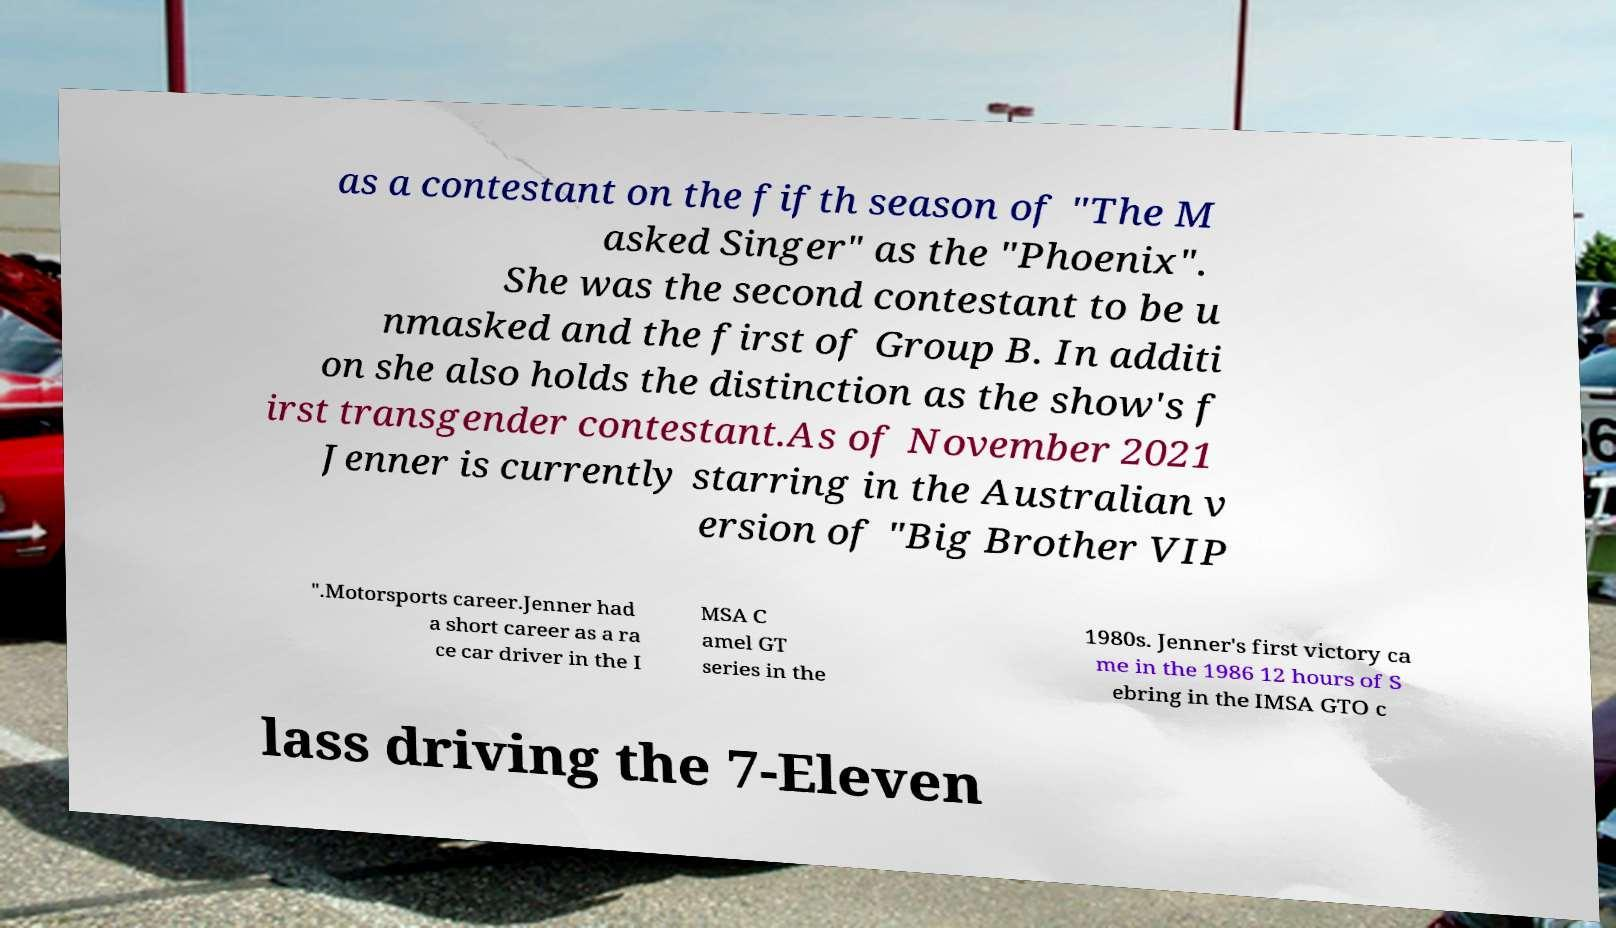There's text embedded in this image that I need extracted. Can you transcribe it verbatim? as a contestant on the fifth season of "The M asked Singer" as the "Phoenix". She was the second contestant to be u nmasked and the first of Group B. In additi on she also holds the distinction as the show's f irst transgender contestant.As of November 2021 Jenner is currently starring in the Australian v ersion of "Big Brother VIP ".Motorsports career.Jenner had a short career as a ra ce car driver in the I MSA C amel GT series in the 1980s. Jenner's first victory ca me in the 1986 12 hours of S ebring in the IMSA GTO c lass driving the 7-Eleven 